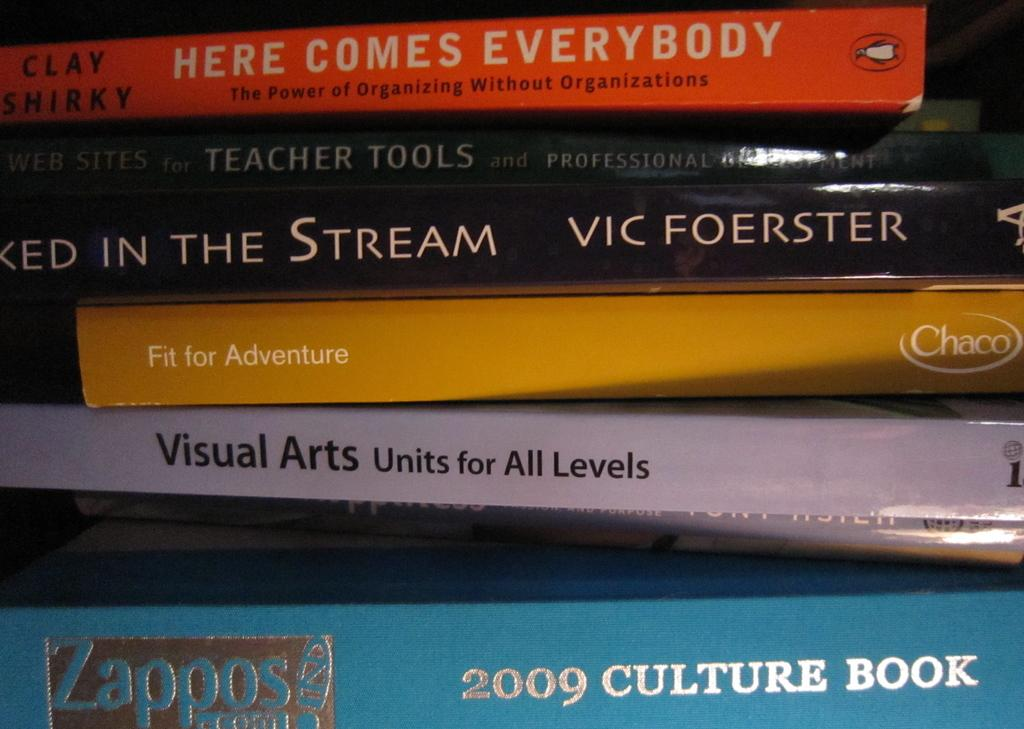Provide a one-sentence caption for the provided image. A stack of books with the spines showing their titles dealing with topics about teaching, learning and adventures. 